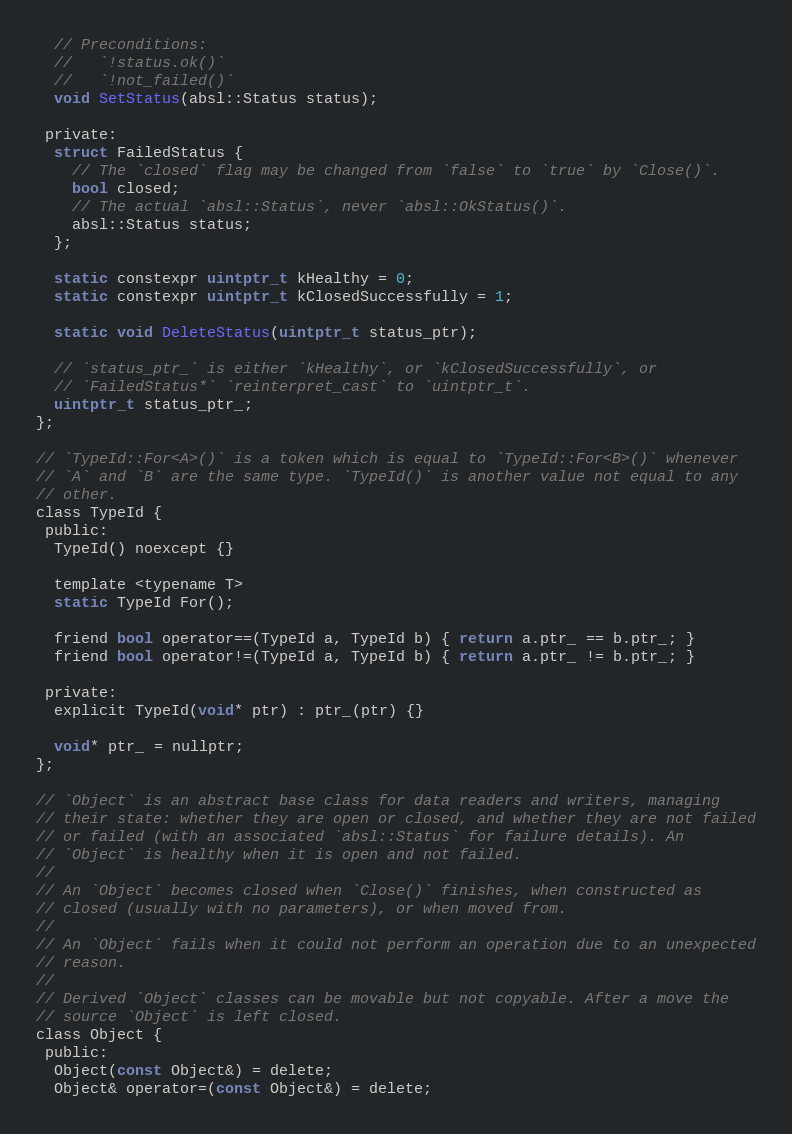<code> <loc_0><loc_0><loc_500><loc_500><_C_>  // Preconditions:
  //   `!status.ok()`
  //   `!not_failed()`
  void SetStatus(absl::Status status);

 private:
  struct FailedStatus {
    // The `closed` flag may be changed from `false` to `true` by `Close()`.
    bool closed;
    // The actual `absl::Status`, never `absl::OkStatus()`.
    absl::Status status;
  };

  static constexpr uintptr_t kHealthy = 0;
  static constexpr uintptr_t kClosedSuccessfully = 1;

  static void DeleteStatus(uintptr_t status_ptr);

  // `status_ptr_` is either `kHealthy`, or `kClosedSuccessfully`, or
  // `FailedStatus*` `reinterpret_cast` to `uintptr_t`.
  uintptr_t status_ptr_;
};

// `TypeId::For<A>()` is a token which is equal to `TypeId::For<B>()` whenever
// `A` and `B` are the same type. `TypeId()` is another value not equal to any
// other.
class TypeId {
 public:
  TypeId() noexcept {}

  template <typename T>
  static TypeId For();

  friend bool operator==(TypeId a, TypeId b) { return a.ptr_ == b.ptr_; }
  friend bool operator!=(TypeId a, TypeId b) { return a.ptr_ != b.ptr_; }

 private:
  explicit TypeId(void* ptr) : ptr_(ptr) {}

  void* ptr_ = nullptr;
};

// `Object` is an abstract base class for data readers and writers, managing
// their state: whether they are open or closed, and whether they are not failed
// or failed (with an associated `absl::Status` for failure details). An
// `Object` is healthy when it is open and not failed.
//
// An `Object` becomes closed when `Close()` finishes, when constructed as
// closed (usually with no parameters), or when moved from.
//
// An `Object` fails when it could not perform an operation due to an unexpected
// reason.
//
// Derived `Object` classes can be movable but not copyable. After a move the
// source `Object` is left closed.
class Object {
 public:
  Object(const Object&) = delete;
  Object& operator=(const Object&) = delete;
</code> 